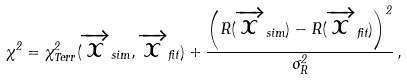<formula> <loc_0><loc_0><loc_500><loc_500>\chi ^ { 2 } = \chi ^ { 2 } _ { T e r r } ( \overrightarrow { x } _ { s i m } , \overrightarrow { x } _ { f i t } ) + \frac { \left ( R ( \overrightarrow { x } _ { s i m } ) - R ( \overrightarrow { x } _ { f i t } ) \right ) ^ { 2 } } { \sigma _ { R } ^ { 2 } } \, ,</formula> 